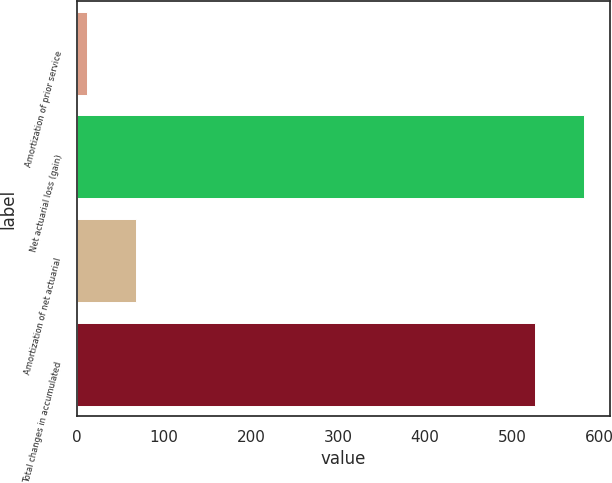Convert chart to OTSL. <chart><loc_0><loc_0><loc_500><loc_500><bar_chart><fcel>Amortization of prior service<fcel>Net actuarial loss (gain)<fcel>Amortization of net actuarial<fcel>Total changes in accumulated<nl><fcel>12<fcel>583.1<fcel>68.1<fcel>527<nl></chart> 